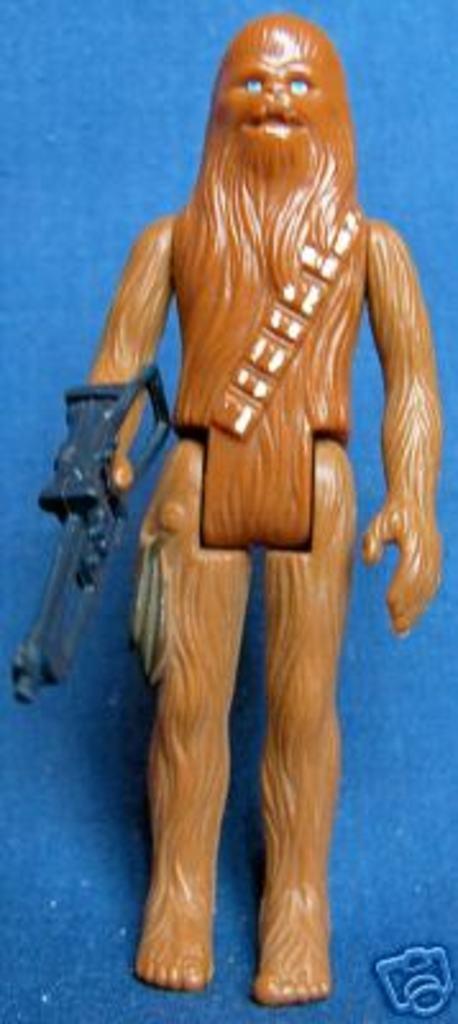Can you describe this image briefly? In this image we can see a doll placed on the surface. At the bottom we can see a logo. 